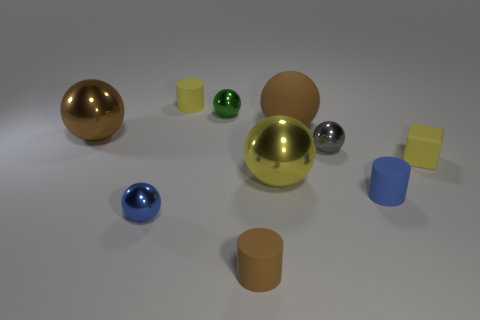Subtract all rubber spheres. How many spheres are left? 5 Subtract all purple blocks. How many brown spheres are left? 2 Subtract 3 spheres. How many spheres are left? 3 Subtract all gray balls. How many balls are left? 5 Subtract all balls. How many objects are left? 4 Subtract all gray cylinders. Subtract all blue balls. How many cylinders are left? 3 Add 1 blue spheres. How many blue spheres exist? 2 Subtract 0 red cubes. How many objects are left? 10 Subtract all yellow metal objects. Subtract all blue matte things. How many objects are left? 8 Add 8 tiny green metallic things. How many tiny green metallic things are left? 9 